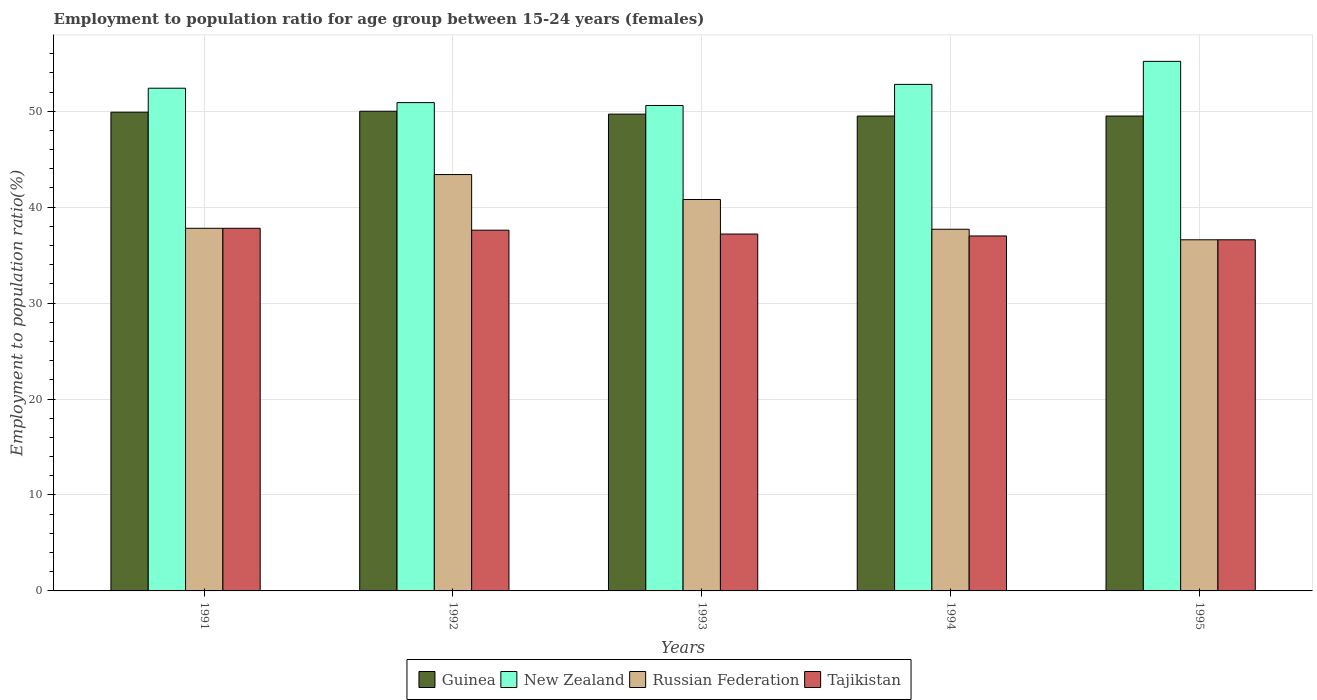How many different coloured bars are there?
Offer a very short reply. 4. Are the number of bars per tick equal to the number of legend labels?
Ensure brevity in your answer.  Yes. How many bars are there on the 5th tick from the left?
Your response must be concise. 4. How many bars are there on the 4th tick from the right?
Your response must be concise. 4. In how many cases, is the number of bars for a given year not equal to the number of legend labels?
Ensure brevity in your answer.  0. What is the employment to population ratio in Tajikistan in 1991?
Provide a short and direct response. 37.8. Across all years, what is the maximum employment to population ratio in New Zealand?
Keep it short and to the point. 55.2. Across all years, what is the minimum employment to population ratio in Guinea?
Your answer should be very brief. 49.5. In which year was the employment to population ratio in Guinea maximum?
Keep it short and to the point. 1992. In which year was the employment to population ratio in Guinea minimum?
Your response must be concise. 1994. What is the total employment to population ratio in Guinea in the graph?
Your response must be concise. 248.6. What is the difference between the employment to population ratio in Tajikistan in 1991 and that in 1995?
Your response must be concise. 1.2. What is the difference between the employment to population ratio in Tajikistan in 1993 and the employment to population ratio in Guinea in 1994?
Your answer should be very brief. -12.3. What is the average employment to population ratio in Russian Federation per year?
Provide a short and direct response. 39.26. In the year 1993, what is the difference between the employment to population ratio in Tajikistan and employment to population ratio in Russian Federation?
Your answer should be compact. -3.6. In how many years, is the employment to population ratio in New Zealand greater than 34 %?
Keep it short and to the point. 5. What is the ratio of the employment to population ratio in New Zealand in 1991 to that in 1992?
Make the answer very short. 1.03. Is the employment to population ratio in Russian Federation in 1993 less than that in 1994?
Offer a very short reply. No. What is the difference between the highest and the second highest employment to population ratio in Guinea?
Make the answer very short. 0.1. What is the difference between the highest and the lowest employment to population ratio in Russian Federation?
Keep it short and to the point. 6.8. What does the 3rd bar from the left in 1992 represents?
Your answer should be compact. Russian Federation. What does the 1st bar from the right in 1991 represents?
Provide a succinct answer. Tajikistan. Is it the case that in every year, the sum of the employment to population ratio in Tajikistan and employment to population ratio in New Zealand is greater than the employment to population ratio in Russian Federation?
Offer a terse response. Yes. What is the difference between two consecutive major ticks on the Y-axis?
Offer a very short reply. 10. Are the values on the major ticks of Y-axis written in scientific E-notation?
Provide a succinct answer. No. Where does the legend appear in the graph?
Keep it short and to the point. Bottom center. How are the legend labels stacked?
Offer a very short reply. Horizontal. What is the title of the graph?
Give a very brief answer. Employment to population ratio for age group between 15-24 years (females). Does "Guinea" appear as one of the legend labels in the graph?
Offer a terse response. Yes. What is the label or title of the X-axis?
Give a very brief answer. Years. What is the label or title of the Y-axis?
Provide a short and direct response. Employment to population ratio(%). What is the Employment to population ratio(%) in Guinea in 1991?
Make the answer very short. 49.9. What is the Employment to population ratio(%) in New Zealand in 1991?
Your answer should be compact. 52.4. What is the Employment to population ratio(%) in Russian Federation in 1991?
Provide a succinct answer. 37.8. What is the Employment to population ratio(%) of Tajikistan in 1991?
Provide a short and direct response. 37.8. What is the Employment to population ratio(%) in Guinea in 1992?
Provide a short and direct response. 50. What is the Employment to population ratio(%) in New Zealand in 1992?
Give a very brief answer. 50.9. What is the Employment to population ratio(%) in Russian Federation in 1992?
Your answer should be very brief. 43.4. What is the Employment to population ratio(%) in Tajikistan in 1992?
Provide a succinct answer. 37.6. What is the Employment to population ratio(%) in Guinea in 1993?
Make the answer very short. 49.7. What is the Employment to population ratio(%) of New Zealand in 1993?
Give a very brief answer. 50.6. What is the Employment to population ratio(%) of Russian Federation in 1993?
Provide a succinct answer. 40.8. What is the Employment to population ratio(%) of Tajikistan in 1993?
Make the answer very short. 37.2. What is the Employment to population ratio(%) of Guinea in 1994?
Your answer should be compact. 49.5. What is the Employment to population ratio(%) in New Zealand in 1994?
Provide a short and direct response. 52.8. What is the Employment to population ratio(%) of Russian Federation in 1994?
Offer a very short reply. 37.7. What is the Employment to population ratio(%) of Guinea in 1995?
Keep it short and to the point. 49.5. What is the Employment to population ratio(%) of New Zealand in 1995?
Offer a terse response. 55.2. What is the Employment to population ratio(%) in Russian Federation in 1995?
Keep it short and to the point. 36.6. What is the Employment to population ratio(%) in Tajikistan in 1995?
Your answer should be compact. 36.6. Across all years, what is the maximum Employment to population ratio(%) of New Zealand?
Give a very brief answer. 55.2. Across all years, what is the maximum Employment to population ratio(%) of Russian Federation?
Your response must be concise. 43.4. Across all years, what is the maximum Employment to population ratio(%) in Tajikistan?
Your answer should be very brief. 37.8. Across all years, what is the minimum Employment to population ratio(%) of Guinea?
Offer a terse response. 49.5. Across all years, what is the minimum Employment to population ratio(%) in New Zealand?
Make the answer very short. 50.6. Across all years, what is the minimum Employment to population ratio(%) of Russian Federation?
Give a very brief answer. 36.6. Across all years, what is the minimum Employment to population ratio(%) of Tajikistan?
Give a very brief answer. 36.6. What is the total Employment to population ratio(%) in Guinea in the graph?
Make the answer very short. 248.6. What is the total Employment to population ratio(%) of New Zealand in the graph?
Your answer should be very brief. 261.9. What is the total Employment to population ratio(%) of Russian Federation in the graph?
Provide a succinct answer. 196.3. What is the total Employment to population ratio(%) of Tajikistan in the graph?
Your response must be concise. 186.2. What is the difference between the Employment to population ratio(%) in New Zealand in 1991 and that in 1992?
Your answer should be compact. 1.5. What is the difference between the Employment to population ratio(%) in Tajikistan in 1991 and that in 1992?
Give a very brief answer. 0.2. What is the difference between the Employment to population ratio(%) of Guinea in 1991 and that in 1994?
Your response must be concise. 0.4. What is the difference between the Employment to population ratio(%) in New Zealand in 1991 and that in 1994?
Ensure brevity in your answer.  -0.4. What is the difference between the Employment to population ratio(%) in Tajikistan in 1991 and that in 1994?
Give a very brief answer. 0.8. What is the difference between the Employment to population ratio(%) of Guinea in 1991 and that in 1995?
Your response must be concise. 0.4. What is the difference between the Employment to population ratio(%) in New Zealand in 1991 and that in 1995?
Offer a very short reply. -2.8. What is the difference between the Employment to population ratio(%) in Tajikistan in 1991 and that in 1995?
Your response must be concise. 1.2. What is the difference between the Employment to population ratio(%) of New Zealand in 1992 and that in 1993?
Your answer should be compact. 0.3. What is the difference between the Employment to population ratio(%) of Tajikistan in 1992 and that in 1993?
Your answer should be compact. 0.4. What is the difference between the Employment to population ratio(%) in Guinea in 1992 and that in 1994?
Ensure brevity in your answer.  0.5. What is the difference between the Employment to population ratio(%) of Russian Federation in 1992 and that in 1994?
Offer a terse response. 5.7. What is the difference between the Employment to population ratio(%) in Tajikistan in 1992 and that in 1994?
Your answer should be compact. 0.6. What is the difference between the Employment to population ratio(%) of Russian Federation in 1992 and that in 1995?
Your answer should be very brief. 6.8. What is the difference between the Employment to population ratio(%) of Tajikistan in 1992 and that in 1995?
Offer a terse response. 1. What is the difference between the Employment to population ratio(%) of Guinea in 1993 and that in 1994?
Ensure brevity in your answer.  0.2. What is the difference between the Employment to population ratio(%) of Russian Federation in 1993 and that in 1994?
Ensure brevity in your answer.  3.1. What is the difference between the Employment to population ratio(%) in Guinea in 1994 and that in 1995?
Keep it short and to the point. 0. What is the difference between the Employment to population ratio(%) of Tajikistan in 1994 and that in 1995?
Make the answer very short. 0.4. What is the difference between the Employment to population ratio(%) of New Zealand in 1991 and the Employment to population ratio(%) of Russian Federation in 1992?
Your answer should be compact. 9. What is the difference between the Employment to population ratio(%) in New Zealand in 1991 and the Employment to population ratio(%) in Russian Federation in 1993?
Provide a succinct answer. 11.6. What is the difference between the Employment to population ratio(%) in New Zealand in 1991 and the Employment to population ratio(%) in Tajikistan in 1993?
Your response must be concise. 15.2. What is the difference between the Employment to population ratio(%) of Russian Federation in 1991 and the Employment to population ratio(%) of Tajikistan in 1993?
Provide a short and direct response. 0.6. What is the difference between the Employment to population ratio(%) of Guinea in 1991 and the Employment to population ratio(%) of Russian Federation in 1994?
Your response must be concise. 12.2. What is the difference between the Employment to population ratio(%) of New Zealand in 1991 and the Employment to population ratio(%) of Russian Federation in 1994?
Offer a terse response. 14.7. What is the difference between the Employment to population ratio(%) of New Zealand in 1991 and the Employment to population ratio(%) of Tajikistan in 1994?
Offer a terse response. 15.4. What is the difference between the Employment to population ratio(%) of Russian Federation in 1991 and the Employment to population ratio(%) of Tajikistan in 1994?
Provide a short and direct response. 0.8. What is the difference between the Employment to population ratio(%) in Guinea in 1991 and the Employment to population ratio(%) in New Zealand in 1995?
Make the answer very short. -5.3. What is the difference between the Employment to population ratio(%) in Guinea in 1991 and the Employment to population ratio(%) in Russian Federation in 1995?
Offer a very short reply. 13.3. What is the difference between the Employment to population ratio(%) of Guinea in 1991 and the Employment to population ratio(%) of Tajikistan in 1995?
Offer a terse response. 13.3. What is the difference between the Employment to population ratio(%) in New Zealand in 1991 and the Employment to population ratio(%) in Russian Federation in 1995?
Provide a succinct answer. 15.8. What is the difference between the Employment to population ratio(%) of Russian Federation in 1991 and the Employment to population ratio(%) of Tajikistan in 1995?
Offer a terse response. 1.2. What is the difference between the Employment to population ratio(%) of Guinea in 1992 and the Employment to population ratio(%) of New Zealand in 1993?
Offer a terse response. -0.6. What is the difference between the Employment to population ratio(%) in New Zealand in 1992 and the Employment to population ratio(%) in Russian Federation in 1993?
Your answer should be compact. 10.1. What is the difference between the Employment to population ratio(%) of New Zealand in 1992 and the Employment to population ratio(%) of Tajikistan in 1993?
Make the answer very short. 13.7. What is the difference between the Employment to population ratio(%) in Guinea in 1992 and the Employment to population ratio(%) in New Zealand in 1994?
Keep it short and to the point. -2.8. What is the difference between the Employment to population ratio(%) of Guinea in 1992 and the Employment to population ratio(%) of Russian Federation in 1994?
Offer a very short reply. 12.3. What is the difference between the Employment to population ratio(%) of Guinea in 1992 and the Employment to population ratio(%) of Tajikistan in 1994?
Provide a succinct answer. 13. What is the difference between the Employment to population ratio(%) of Russian Federation in 1992 and the Employment to population ratio(%) of Tajikistan in 1994?
Provide a succinct answer. 6.4. What is the difference between the Employment to population ratio(%) of Guinea in 1992 and the Employment to population ratio(%) of New Zealand in 1995?
Provide a succinct answer. -5.2. What is the difference between the Employment to population ratio(%) of New Zealand in 1992 and the Employment to population ratio(%) of Russian Federation in 1995?
Provide a short and direct response. 14.3. What is the difference between the Employment to population ratio(%) of New Zealand in 1992 and the Employment to population ratio(%) of Tajikistan in 1995?
Your answer should be very brief. 14.3. What is the difference between the Employment to population ratio(%) of Russian Federation in 1992 and the Employment to population ratio(%) of Tajikistan in 1995?
Give a very brief answer. 6.8. What is the difference between the Employment to population ratio(%) in Guinea in 1993 and the Employment to population ratio(%) in New Zealand in 1994?
Your answer should be very brief. -3.1. What is the difference between the Employment to population ratio(%) in Guinea in 1993 and the Employment to population ratio(%) in Russian Federation in 1994?
Keep it short and to the point. 12. What is the difference between the Employment to population ratio(%) in New Zealand in 1993 and the Employment to population ratio(%) in Russian Federation in 1994?
Offer a terse response. 12.9. What is the difference between the Employment to population ratio(%) in Russian Federation in 1993 and the Employment to population ratio(%) in Tajikistan in 1994?
Offer a very short reply. 3.8. What is the difference between the Employment to population ratio(%) of Guinea in 1993 and the Employment to population ratio(%) of New Zealand in 1995?
Offer a terse response. -5.5. What is the difference between the Employment to population ratio(%) in New Zealand in 1993 and the Employment to population ratio(%) in Russian Federation in 1995?
Provide a succinct answer. 14. What is the difference between the Employment to population ratio(%) of Guinea in 1994 and the Employment to population ratio(%) of New Zealand in 1995?
Your answer should be compact. -5.7. What is the difference between the Employment to population ratio(%) in New Zealand in 1994 and the Employment to population ratio(%) in Russian Federation in 1995?
Ensure brevity in your answer.  16.2. What is the difference between the Employment to population ratio(%) of Russian Federation in 1994 and the Employment to population ratio(%) of Tajikistan in 1995?
Your answer should be compact. 1.1. What is the average Employment to population ratio(%) of Guinea per year?
Make the answer very short. 49.72. What is the average Employment to population ratio(%) in New Zealand per year?
Keep it short and to the point. 52.38. What is the average Employment to population ratio(%) of Russian Federation per year?
Provide a succinct answer. 39.26. What is the average Employment to population ratio(%) of Tajikistan per year?
Make the answer very short. 37.24. In the year 1991, what is the difference between the Employment to population ratio(%) in Guinea and Employment to population ratio(%) in Russian Federation?
Keep it short and to the point. 12.1. In the year 1992, what is the difference between the Employment to population ratio(%) in Guinea and Employment to population ratio(%) in Russian Federation?
Offer a terse response. 6.6. In the year 1992, what is the difference between the Employment to population ratio(%) in Guinea and Employment to population ratio(%) in Tajikistan?
Offer a very short reply. 12.4. In the year 1992, what is the difference between the Employment to population ratio(%) of New Zealand and Employment to population ratio(%) of Tajikistan?
Give a very brief answer. 13.3. In the year 1992, what is the difference between the Employment to population ratio(%) in Russian Federation and Employment to population ratio(%) in Tajikistan?
Your answer should be compact. 5.8. In the year 1993, what is the difference between the Employment to population ratio(%) of New Zealand and Employment to population ratio(%) of Russian Federation?
Keep it short and to the point. 9.8. In the year 1993, what is the difference between the Employment to population ratio(%) in New Zealand and Employment to population ratio(%) in Tajikistan?
Provide a succinct answer. 13.4. In the year 1993, what is the difference between the Employment to population ratio(%) in Russian Federation and Employment to population ratio(%) in Tajikistan?
Offer a terse response. 3.6. In the year 1994, what is the difference between the Employment to population ratio(%) in Guinea and Employment to population ratio(%) in Russian Federation?
Provide a short and direct response. 11.8. In the year 1995, what is the difference between the Employment to population ratio(%) of Guinea and Employment to population ratio(%) of Tajikistan?
Keep it short and to the point. 12.9. In the year 1995, what is the difference between the Employment to population ratio(%) in New Zealand and Employment to population ratio(%) in Russian Federation?
Offer a terse response. 18.6. In the year 1995, what is the difference between the Employment to population ratio(%) of New Zealand and Employment to population ratio(%) of Tajikistan?
Your answer should be compact. 18.6. In the year 1995, what is the difference between the Employment to population ratio(%) of Russian Federation and Employment to population ratio(%) of Tajikistan?
Provide a succinct answer. 0. What is the ratio of the Employment to population ratio(%) in New Zealand in 1991 to that in 1992?
Give a very brief answer. 1.03. What is the ratio of the Employment to population ratio(%) of Russian Federation in 1991 to that in 1992?
Your answer should be compact. 0.87. What is the ratio of the Employment to population ratio(%) in Tajikistan in 1991 to that in 1992?
Offer a terse response. 1.01. What is the ratio of the Employment to population ratio(%) in New Zealand in 1991 to that in 1993?
Your answer should be compact. 1.04. What is the ratio of the Employment to population ratio(%) of Russian Federation in 1991 to that in 1993?
Offer a terse response. 0.93. What is the ratio of the Employment to population ratio(%) in Tajikistan in 1991 to that in 1993?
Offer a terse response. 1.02. What is the ratio of the Employment to population ratio(%) of Guinea in 1991 to that in 1994?
Offer a terse response. 1.01. What is the ratio of the Employment to population ratio(%) of New Zealand in 1991 to that in 1994?
Provide a short and direct response. 0.99. What is the ratio of the Employment to population ratio(%) of Tajikistan in 1991 to that in 1994?
Offer a terse response. 1.02. What is the ratio of the Employment to population ratio(%) in New Zealand in 1991 to that in 1995?
Offer a terse response. 0.95. What is the ratio of the Employment to population ratio(%) of Russian Federation in 1991 to that in 1995?
Make the answer very short. 1.03. What is the ratio of the Employment to population ratio(%) of Tajikistan in 1991 to that in 1995?
Provide a succinct answer. 1.03. What is the ratio of the Employment to population ratio(%) of Guinea in 1992 to that in 1993?
Give a very brief answer. 1.01. What is the ratio of the Employment to population ratio(%) of New Zealand in 1992 to that in 1993?
Provide a short and direct response. 1.01. What is the ratio of the Employment to population ratio(%) of Russian Federation in 1992 to that in 1993?
Offer a very short reply. 1.06. What is the ratio of the Employment to population ratio(%) of Tajikistan in 1992 to that in 1993?
Keep it short and to the point. 1.01. What is the ratio of the Employment to population ratio(%) in Guinea in 1992 to that in 1994?
Offer a very short reply. 1.01. What is the ratio of the Employment to population ratio(%) in New Zealand in 1992 to that in 1994?
Your answer should be very brief. 0.96. What is the ratio of the Employment to population ratio(%) in Russian Federation in 1992 to that in 1994?
Your answer should be compact. 1.15. What is the ratio of the Employment to population ratio(%) of Tajikistan in 1992 to that in 1994?
Your answer should be very brief. 1.02. What is the ratio of the Employment to population ratio(%) in New Zealand in 1992 to that in 1995?
Keep it short and to the point. 0.92. What is the ratio of the Employment to population ratio(%) of Russian Federation in 1992 to that in 1995?
Provide a short and direct response. 1.19. What is the ratio of the Employment to population ratio(%) of Tajikistan in 1992 to that in 1995?
Give a very brief answer. 1.03. What is the ratio of the Employment to population ratio(%) of Guinea in 1993 to that in 1994?
Make the answer very short. 1. What is the ratio of the Employment to population ratio(%) of New Zealand in 1993 to that in 1994?
Provide a succinct answer. 0.96. What is the ratio of the Employment to population ratio(%) in Russian Federation in 1993 to that in 1994?
Offer a very short reply. 1.08. What is the ratio of the Employment to population ratio(%) of Tajikistan in 1993 to that in 1994?
Offer a terse response. 1.01. What is the ratio of the Employment to population ratio(%) in Guinea in 1993 to that in 1995?
Offer a terse response. 1. What is the ratio of the Employment to population ratio(%) in Russian Federation in 1993 to that in 1995?
Provide a short and direct response. 1.11. What is the ratio of the Employment to population ratio(%) of Tajikistan in 1993 to that in 1995?
Your response must be concise. 1.02. What is the ratio of the Employment to population ratio(%) in New Zealand in 1994 to that in 1995?
Make the answer very short. 0.96. What is the ratio of the Employment to population ratio(%) of Russian Federation in 1994 to that in 1995?
Your response must be concise. 1.03. What is the ratio of the Employment to population ratio(%) of Tajikistan in 1994 to that in 1995?
Ensure brevity in your answer.  1.01. What is the difference between the highest and the second highest Employment to population ratio(%) of New Zealand?
Offer a terse response. 2.4. What is the difference between the highest and the second highest Employment to population ratio(%) in Russian Federation?
Offer a very short reply. 2.6. What is the difference between the highest and the second highest Employment to population ratio(%) in Tajikistan?
Make the answer very short. 0.2. What is the difference between the highest and the lowest Employment to population ratio(%) in Russian Federation?
Keep it short and to the point. 6.8. 